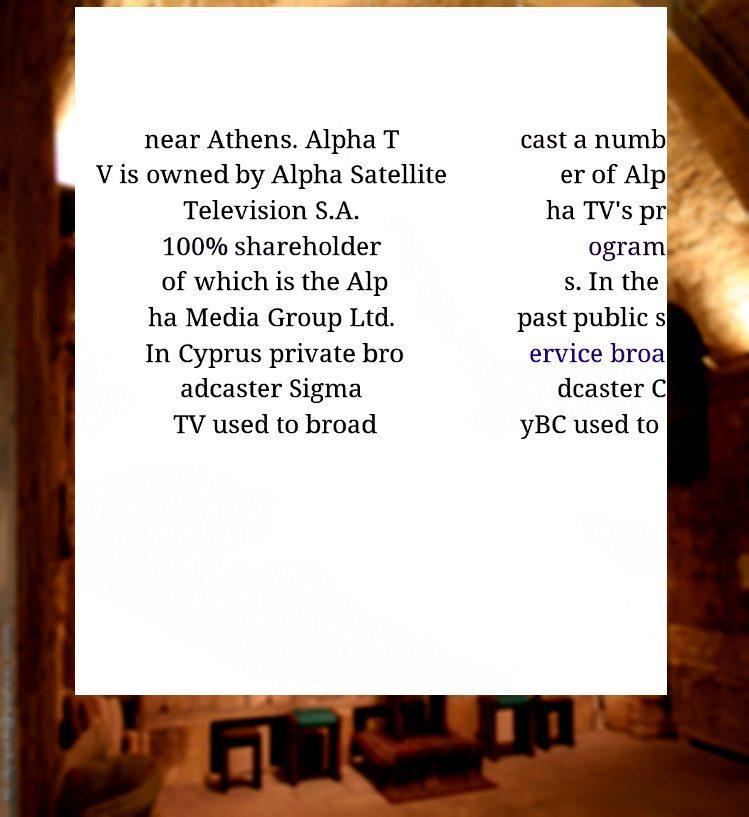I need the written content from this picture converted into text. Can you do that? near Athens. Alpha T V is owned by Alpha Satellite Television S.A. 100% shareholder of which is the Alp ha Media Group Ltd. In Cyprus private bro adcaster Sigma TV used to broad cast a numb er of Alp ha TV's pr ogram s. In the past public s ervice broa dcaster C yBC used to 